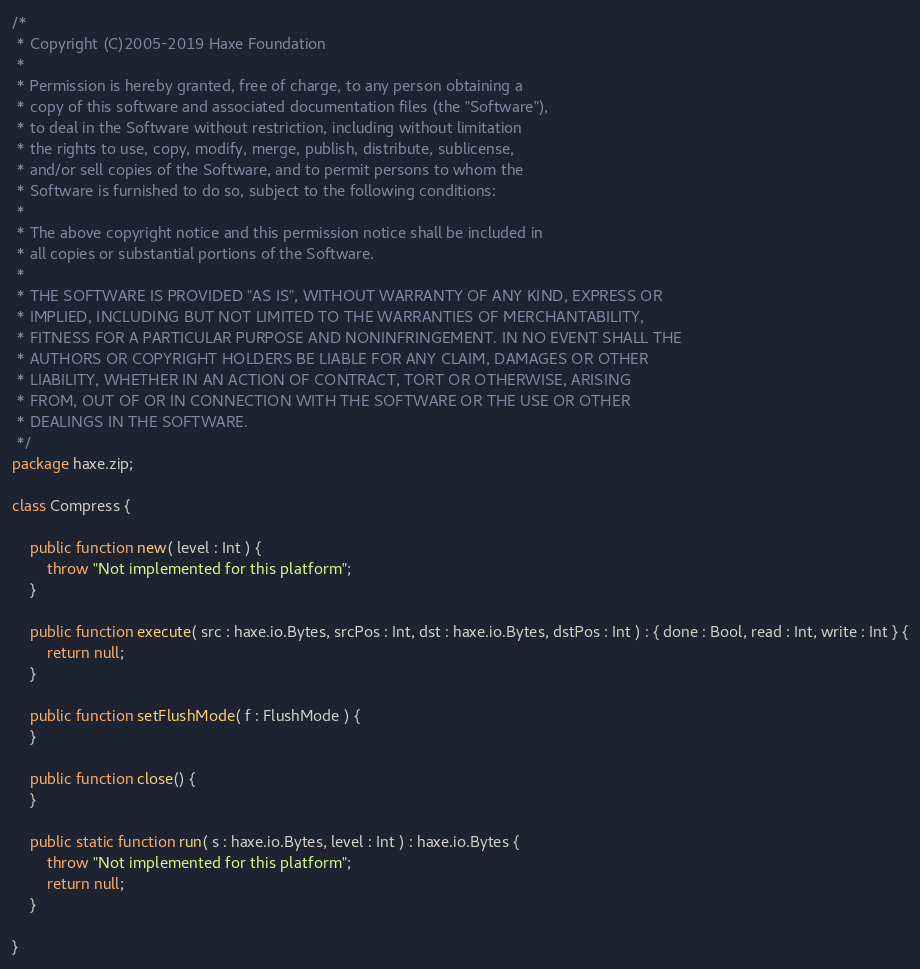Convert code to text. <code><loc_0><loc_0><loc_500><loc_500><_Haxe_>/*
 * Copyright (C)2005-2019 Haxe Foundation
 *
 * Permission is hereby granted, free of charge, to any person obtaining a
 * copy of this software and associated documentation files (the "Software"),
 * to deal in the Software without restriction, including without limitation
 * the rights to use, copy, modify, merge, publish, distribute, sublicense,
 * and/or sell copies of the Software, and to permit persons to whom the
 * Software is furnished to do so, subject to the following conditions:
 *
 * The above copyright notice and this permission notice shall be included in
 * all copies or substantial portions of the Software.
 *
 * THE SOFTWARE IS PROVIDED "AS IS", WITHOUT WARRANTY OF ANY KIND, EXPRESS OR
 * IMPLIED, INCLUDING BUT NOT LIMITED TO THE WARRANTIES OF MERCHANTABILITY,
 * FITNESS FOR A PARTICULAR PURPOSE AND NONINFRINGEMENT. IN NO EVENT SHALL THE
 * AUTHORS OR COPYRIGHT HOLDERS BE LIABLE FOR ANY CLAIM, DAMAGES OR OTHER
 * LIABILITY, WHETHER IN AN ACTION OF CONTRACT, TORT OR OTHERWISE, ARISING
 * FROM, OUT OF OR IN CONNECTION WITH THE SOFTWARE OR THE USE OR OTHER
 * DEALINGS IN THE SOFTWARE.
 */
package haxe.zip;

class Compress {

	public function new( level : Int ) {
		throw "Not implemented for this platform";
	}

	public function execute( src : haxe.io.Bytes, srcPos : Int, dst : haxe.io.Bytes, dstPos : Int ) : { done : Bool, read : Int, write : Int } {
		return null;
	}

	public function setFlushMode( f : FlushMode ) {
	}

	public function close() {
	}

	public static function run( s : haxe.io.Bytes, level : Int ) : haxe.io.Bytes {
		throw "Not implemented for this platform";
		return null;
	}

}
</code> 